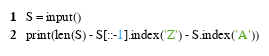Convert code to text. <code><loc_0><loc_0><loc_500><loc_500><_Python_>S = input()
print(len(S) - S[::-1].index('Z') - S.index('A'))</code> 